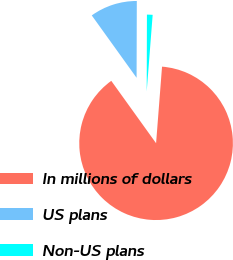Convert chart to OTSL. <chart><loc_0><loc_0><loc_500><loc_500><pie_chart><fcel>In millions of dollars<fcel>US plans<fcel>Non-US plans<nl><fcel>88.85%<fcel>9.96%<fcel>1.19%<nl></chart> 